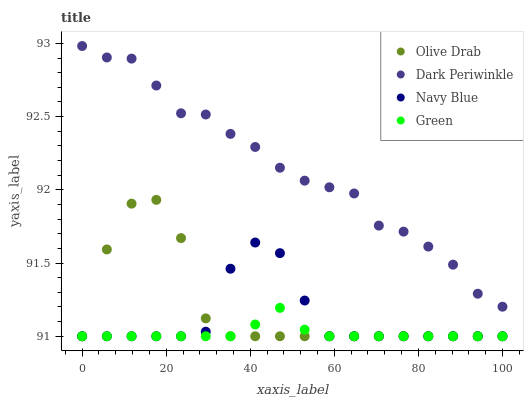Does Green have the minimum area under the curve?
Answer yes or no. Yes. Does Dark Periwinkle have the maximum area under the curve?
Answer yes or no. Yes. Does Dark Periwinkle have the minimum area under the curve?
Answer yes or no. No. Does Green have the maximum area under the curve?
Answer yes or no. No. Is Green the smoothest?
Answer yes or no. Yes. Is Olive Drab the roughest?
Answer yes or no. Yes. Is Dark Periwinkle the smoothest?
Answer yes or no. No. Is Dark Periwinkle the roughest?
Answer yes or no. No. Does Navy Blue have the lowest value?
Answer yes or no. Yes. Does Dark Periwinkle have the lowest value?
Answer yes or no. No. Does Dark Periwinkle have the highest value?
Answer yes or no. Yes. Does Green have the highest value?
Answer yes or no. No. Is Green less than Dark Periwinkle?
Answer yes or no. Yes. Is Dark Periwinkle greater than Navy Blue?
Answer yes or no. Yes. Does Olive Drab intersect Green?
Answer yes or no. Yes. Is Olive Drab less than Green?
Answer yes or no. No. Is Olive Drab greater than Green?
Answer yes or no. No. Does Green intersect Dark Periwinkle?
Answer yes or no. No. 